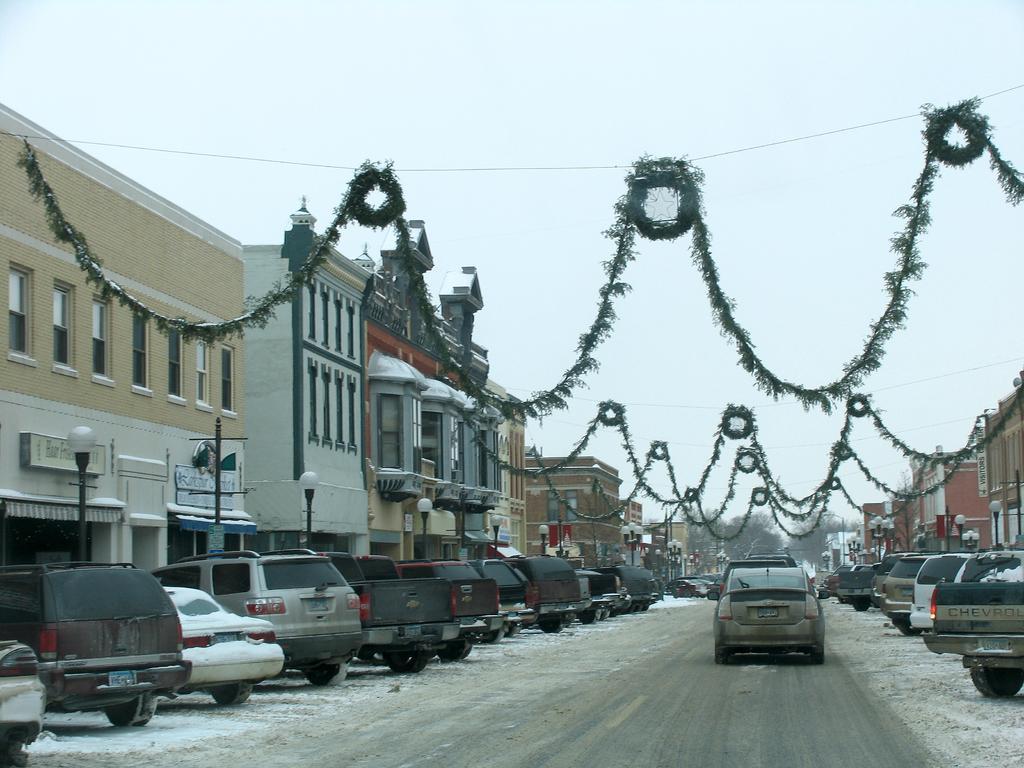How would you summarize this image in a sentence or two? In this image I can see the road, few vehicles on the ground, few poles, few lights and few buildings on both sides of the road. I can see few decorative items hanged to the rope and in the background I can see few trees and the sky. 